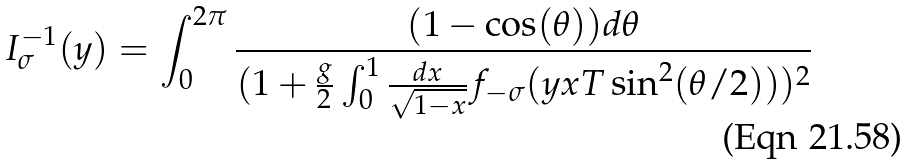Convert formula to latex. <formula><loc_0><loc_0><loc_500><loc_500>I _ { \sigma } ^ { - 1 } ( y ) = \int _ { 0 } ^ { 2 \pi } \frac { ( 1 - \cos ( \theta ) ) d \theta } { ( 1 + \frac { g } { 2 } \int _ { 0 } ^ { 1 } \frac { d x } { \sqrt { 1 - x } } f _ { - \sigma } ( y x T \sin ^ { 2 } ( \theta / 2 ) ) ) ^ { 2 } }</formula> 